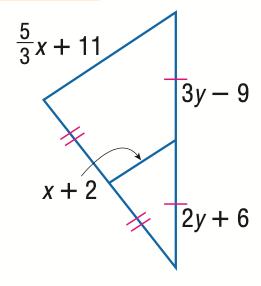Answer the mathemtical geometry problem and directly provide the correct option letter.
Question: Find y.
Choices: A: 15 B: 18 C: 21 D: 24 A 